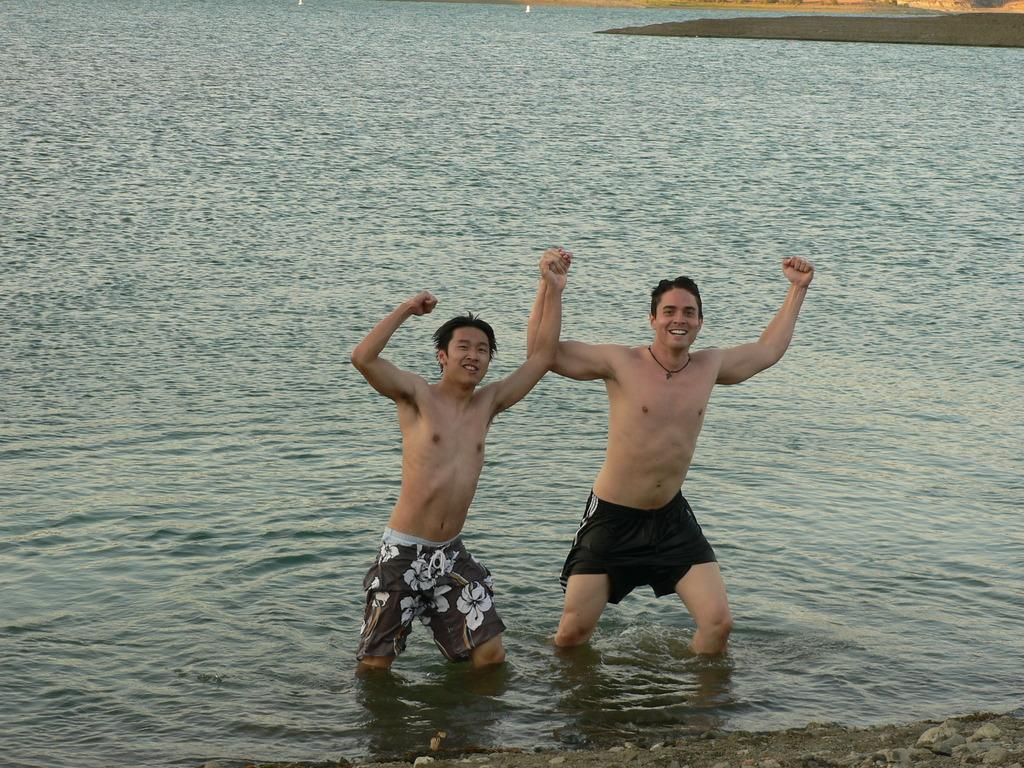What are the people in the image doing? The people in the image are in the water. What can be seen below the water's surface? There are stones at the bottom of the water. What is visible above the water's surface? The ground is visible in the image. What type of cough can be heard from the people in the image? There is no indication of any coughing in the image, as it features people in the water. 